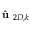<formula> <loc_0><loc_0><loc_500><loc_500>\hat { u } _ { 2 D , k }</formula> 